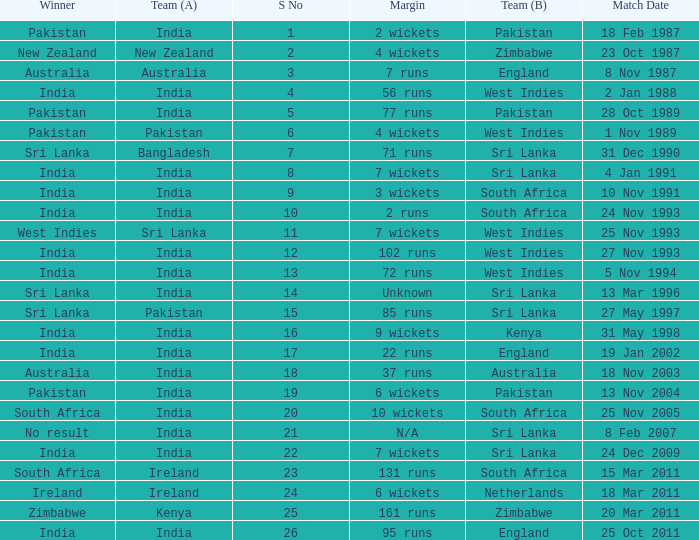Who won the match when the margin was 131 runs? South Africa. 